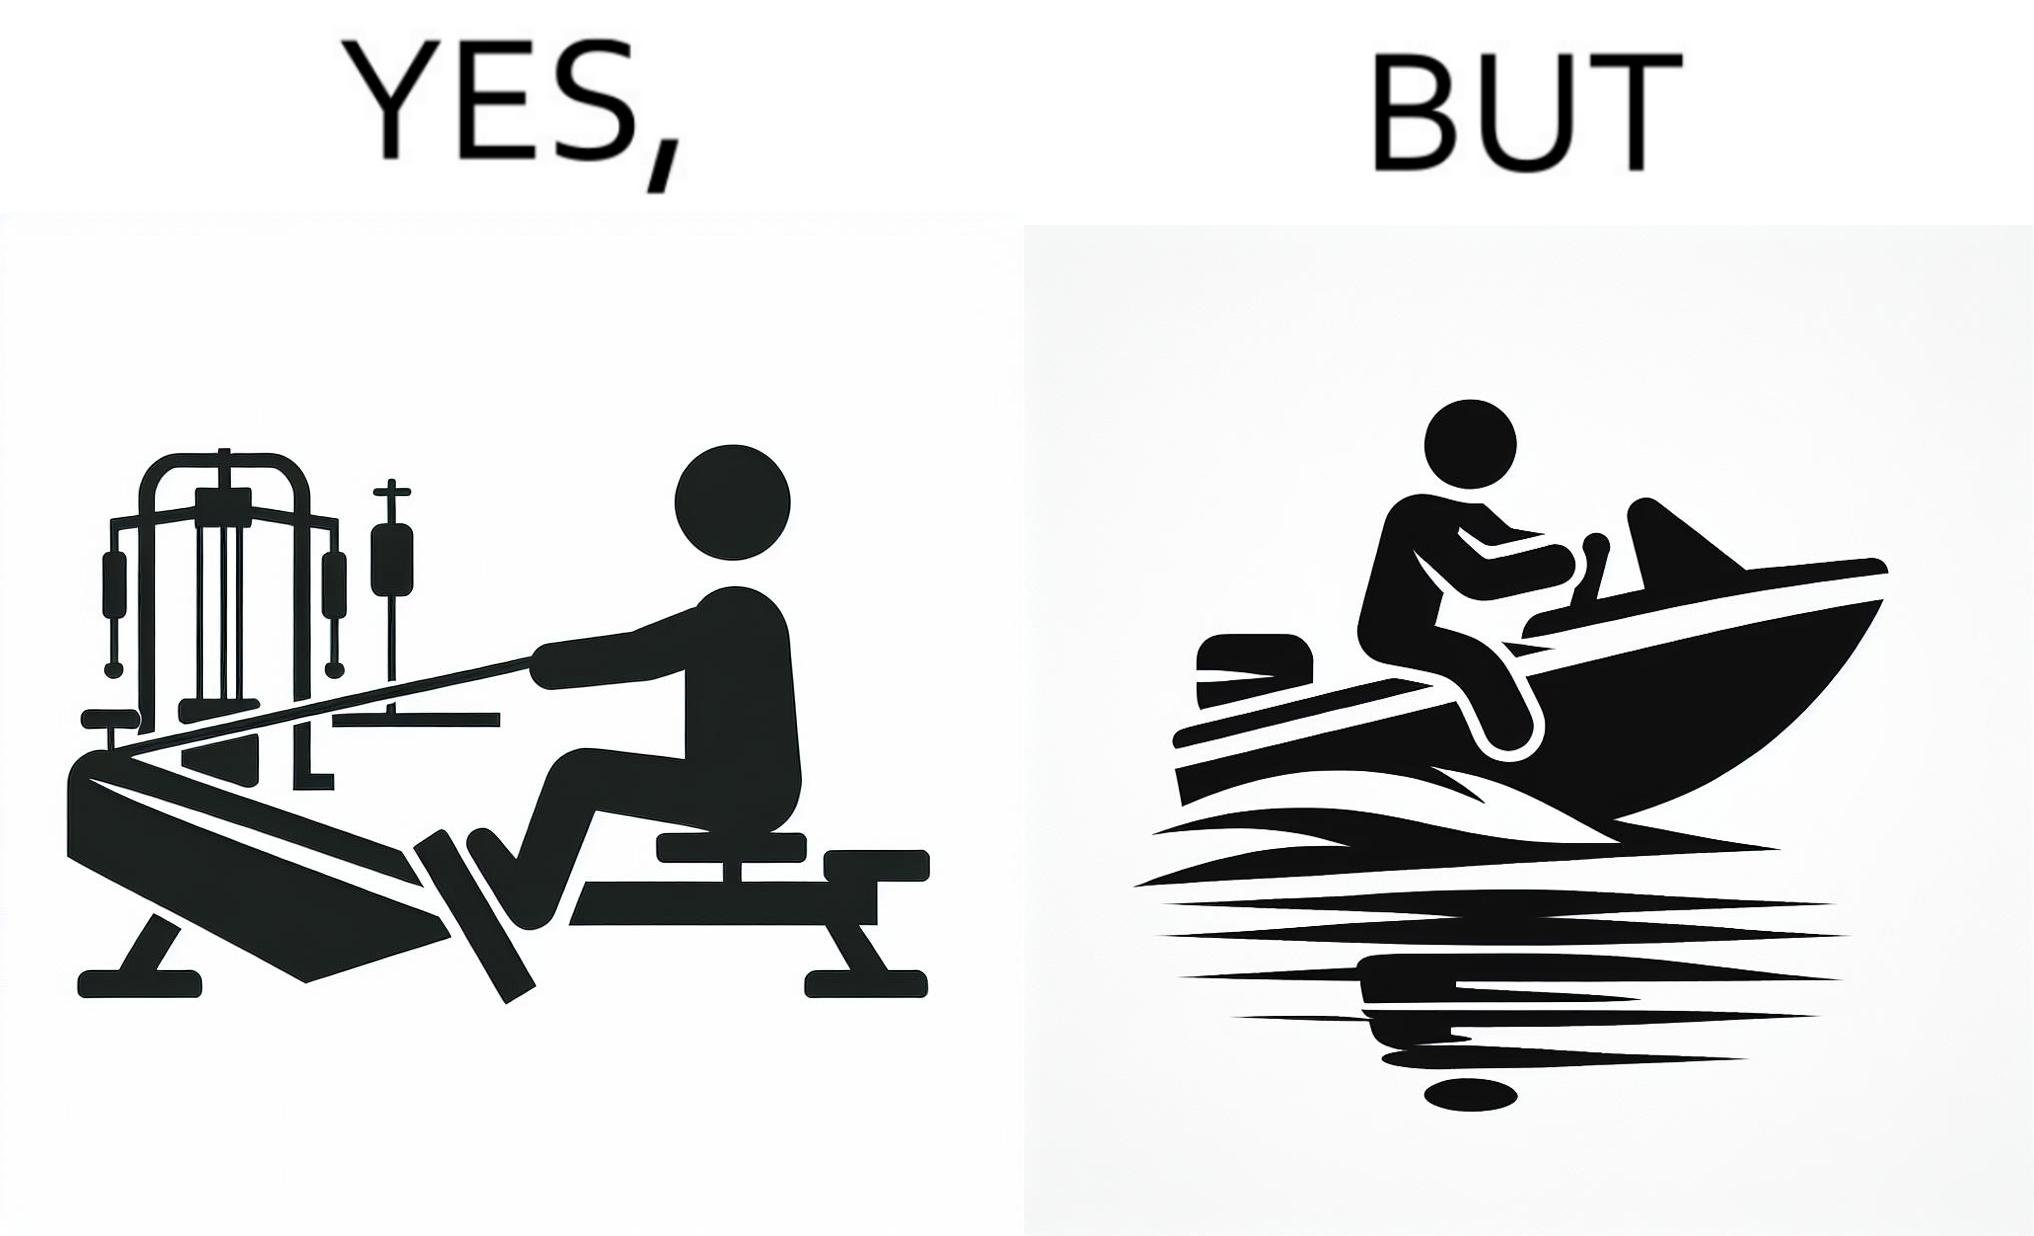What does this image depict? The image is ironic, because people often use rowing machine at the gym don't prefer rowing when it comes to boats 